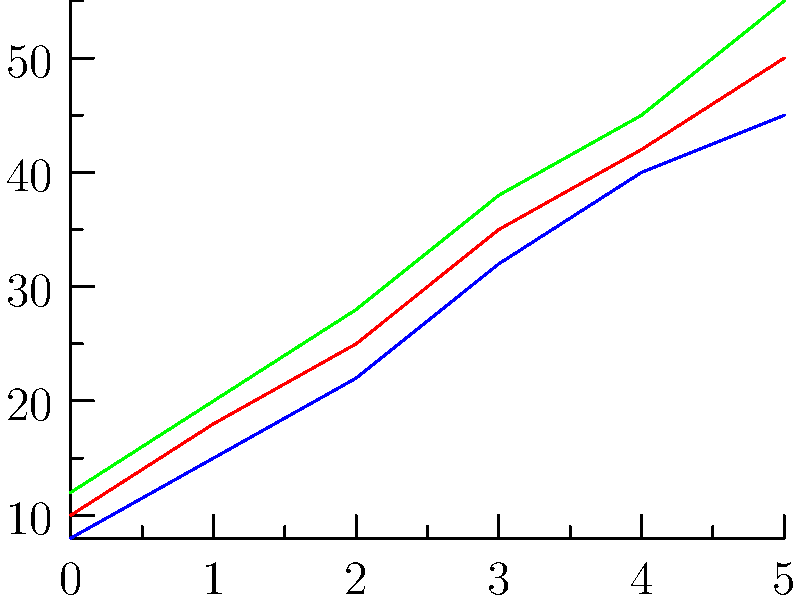Based on the line graph showing the growth rates of three disease-resistant grape varieties over 5 years, which variety consistently demonstrates the highest growth rate, and what is its growth rate in the final year? To answer this question, we need to analyze the growth rates of the three varieties over the 5-year period:

1. Identify the three varieties:
   - Variety A (red line)
   - Variety B (blue line)
   - Variety C (green line)

2. Compare the growth rates:
   - Variety C (green line) consistently shows the highest position on the graph for all years.
   - This indicates that Variety C has the highest growth rate throughout the 5-year period.

3. Determine the growth rate of Variety C in the final year:
   - The x-axis represents years, with the final point being year 5.
   - The y-axis represents the growth rate in cm/year.
   - Tracing the green line (Variety C) to year 5, we can see it reaches a value of 55 cm/year.

Therefore, Variety C consistently demonstrates the highest growth rate, and its growth rate in the final year (year 5) is 55 cm/year.
Answer: Variety C; 55 cm/year 